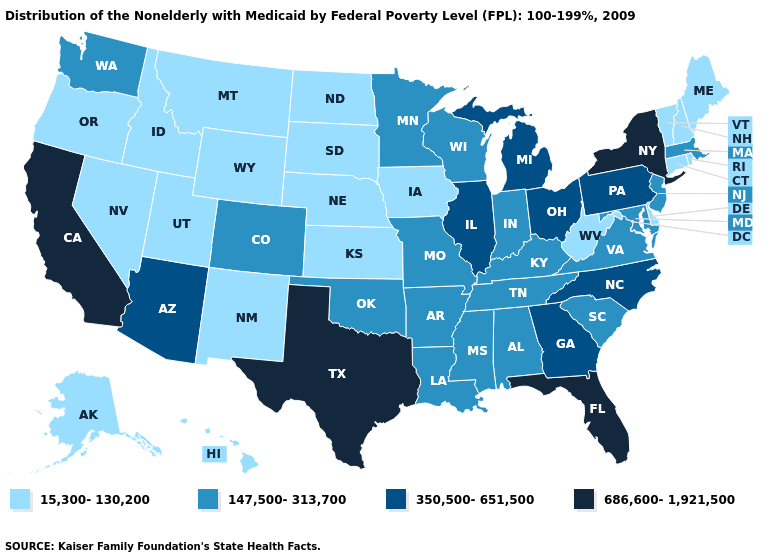What is the value of Montana?
Concise answer only. 15,300-130,200. Does California have the highest value in the USA?
Give a very brief answer. Yes. Which states hav the highest value in the MidWest?
Short answer required. Illinois, Michigan, Ohio. Name the states that have a value in the range 686,600-1,921,500?
Concise answer only. California, Florida, New York, Texas. Name the states that have a value in the range 350,500-651,500?
Give a very brief answer. Arizona, Georgia, Illinois, Michigan, North Carolina, Ohio, Pennsylvania. Name the states that have a value in the range 350,500-651,500?
Quick response, please. Arizona, Georgia, Illinois, Michigan, North Carolina, Ohio, Pennsylvania. How many symbols are there in the legend?
Write a very short answer. 4. Which states have the lowest value in the South?
Write a very short answer. Delaware, West Virginia. Name the states that have a value in the range 350,500-651,500?
Quick response, please. Arizona, Georgia, Illinois, Michigan, North Carolina, Ohio, Pennsylvania. How many symbols are there in the legend?
Write a very short answer. 4. Name the states that have a value in the range 686,600-1,921,500?
Answer briefly. California, Florida, New York, Texas. Does the map have missing data?
Give a very brief answer. No. Does Mississippi have a higher value than Georgia?
Concise answer only. No. What is the value of Nebraska?
Quick response, please. 15,300-130,200. Does Florida have the highest value in the South?
Answer briefly. Yes. 